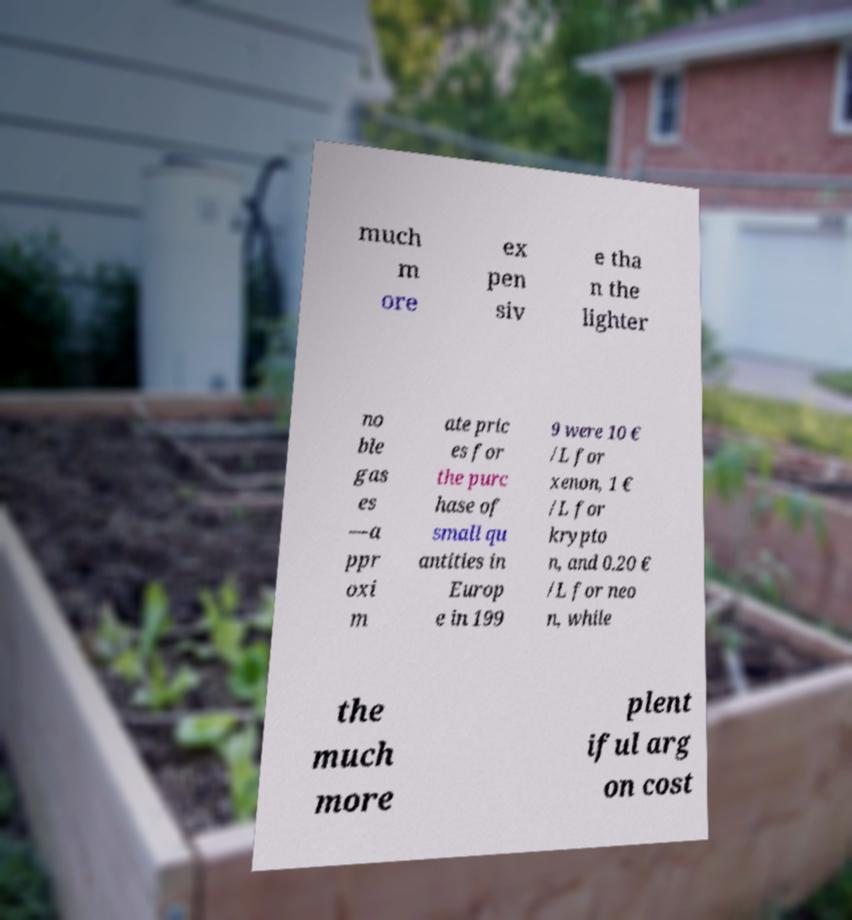Could you extract and type out the text from this image? much m ore ex pen siv e tha n the lighter no ble gas es —a ppr oxi m ate pric es for the purc hase of small qu antities in Europ e in 199 9 were 10 € /L for xenon, 1 € /L for krypto n, and 0.20 € /L for neo n, while the much more plent iful arg on cost 